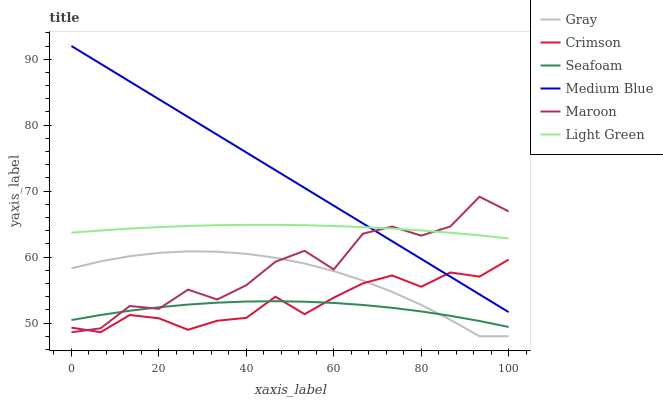Does Seafoam have the minimum area under the curve?
Answer yes or no. Yes. Does Medium Blue have the maximum area under the curve?
Answer yes or no. Yes. Does Medium Blue have the minimum area under the curve?
Answer yes or no. No. Does Seafoam have the maximum area under the curve?
Answer yes or no. No. Is Medium Blue the smoothest?
Answer yes or no. Yes. Is Maroon the roughest?
Answer yes or no. Yes. Is Seafoam the smoothest?
Answer yes or no. No. Is Seafoam the roughest?
Answer yes or no. No. Does Gray have the lowest value?
Answer yes or no. Yes. Does Medium Blue have the lowest value?
Answer yes or no. No. Does Medium Blue have the highest value?
Answer yes or no. Yes. Does Seafoam have the highest value?
Answer yes or no. No. Is Seafoam less than Light Green?
Answer yes or no. Yes. Is Light Green greater than Gray?
Answer yes or no. Yes. Does Seafoam intersect Maroon?
Answer yes or no. Yes. Is Seafoam less than Maroon?
Answer yes or no. No. Is Seafoam greater than Maroon?
Answer yes or no. No. Does Seafoam intersect Light Green?
Answer yes or no. No. 